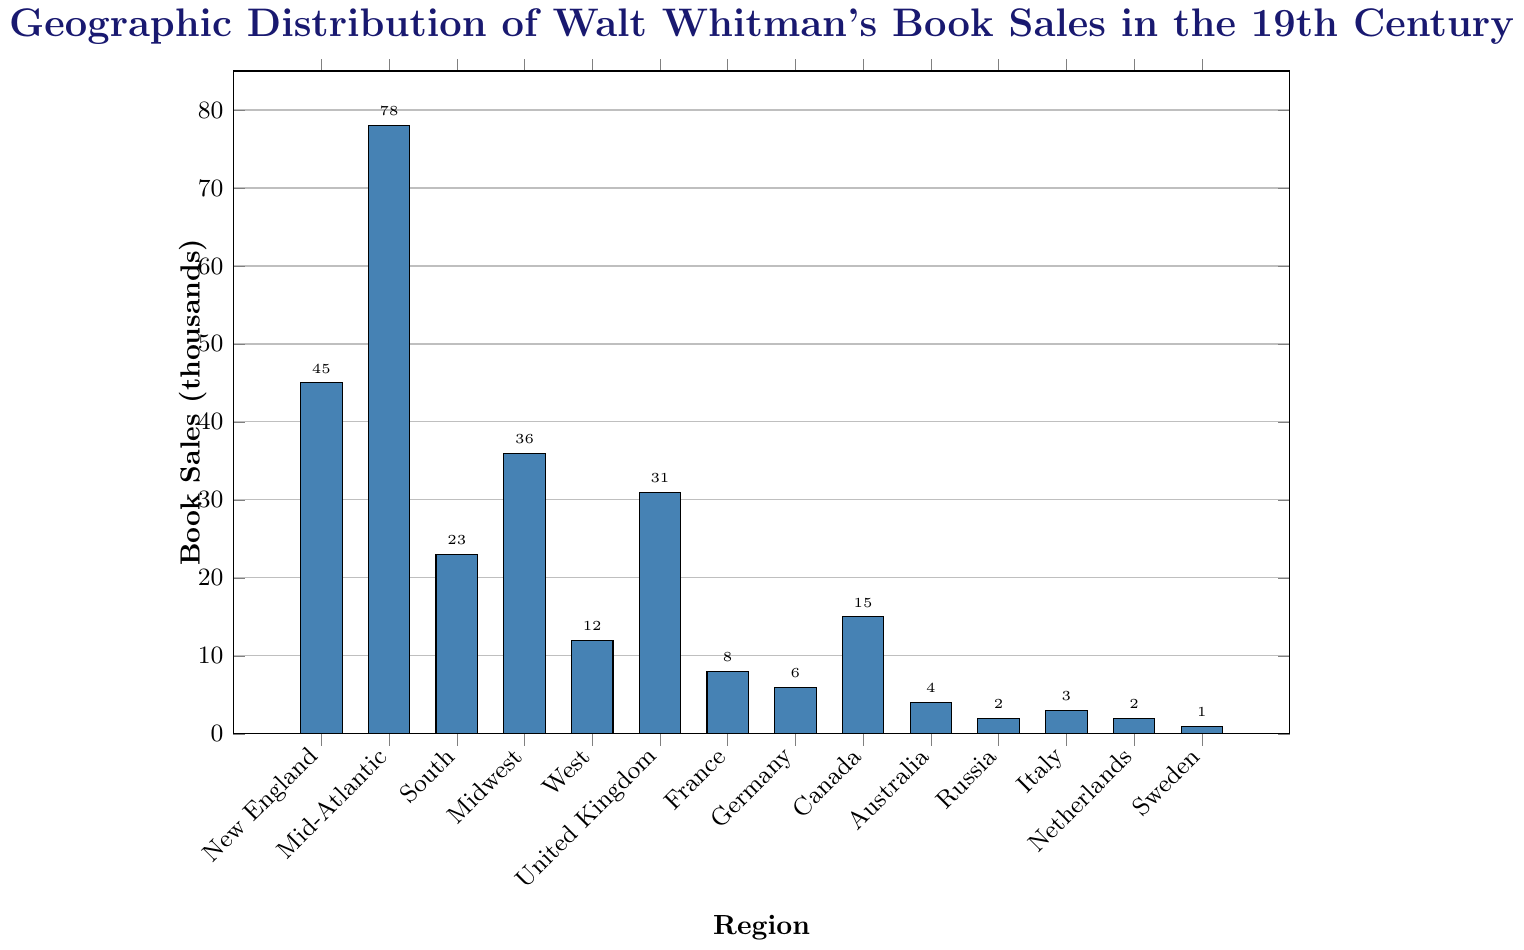What's the region with the highest number of book sales? The highest bar in the chart represents the Mid-Atlantic region with 78 thousand book sales.
Answer: Mid-Atlantic What is the combined book sales for the United Kingdom and Canada? The book sales for the United Kingdom are 31 thousand and for Canada are 15 thousand. Summing them: 31 + 15 = 46.
Answer: 46 thousand Which region has fewer book sales, the South or the Midwest? The chart shows the South with 23 thousand book sales and the Midwest with 36 thousand book sales. 23 is less than 36.
Answer: South How many regions have book sales below 10 thousand? From the figure, France (8), Germany (6), Australia (4), Russia (2), Italy (3), Netherlands (2), and Sweden (1) all have book sales below 10 thousand. Counting these regions gives seven.
Answer: 7 regions What is the difference in book sales between New England and the West? New England has 45 thousand book sales, and the West has 12 thousand. The difference is 45 - 12 = 33.
Answer: 33 thousand Are there more book sales in the United Kingdom or in Canada? The United Kingdom has 31 thousand book sales, and Canada has 15 thousand book sales. 31 is greater than 15.
Answer: United Kingdom What is the average book sales for New England, Mid-Atlantic, and South regions? The book sales are 45, 78, and 23 thousand for New England, Mid-Atlantic, and South respectively. Summing them gives 45 + 78 + 23 = 146. Then dividing by 3 for the average: 146 / 3 ≈ 48.67.
Answer: Approximately 48.67 thousand How many regions have over 30 thousand book sales? The regions with over 30 thousand book sales are Mid-Atlantic (78), New England (45), and United Kingdom (31). There are 3 regions.
Answer: 3 regions Which region has the least number of book sales? The shortest bar in the chart is for Sweden with 1 thousand book sales.
Answer: Sweden What's the total book sales for all regions combined? Summing all the book sales from the chart: 45 + 78 + 23 + 36 + 12 + 31 + 8 + 6 + 15 + 4 + 2 + 3 + 2 + 1 = 266.
Answer: 266 thousand 